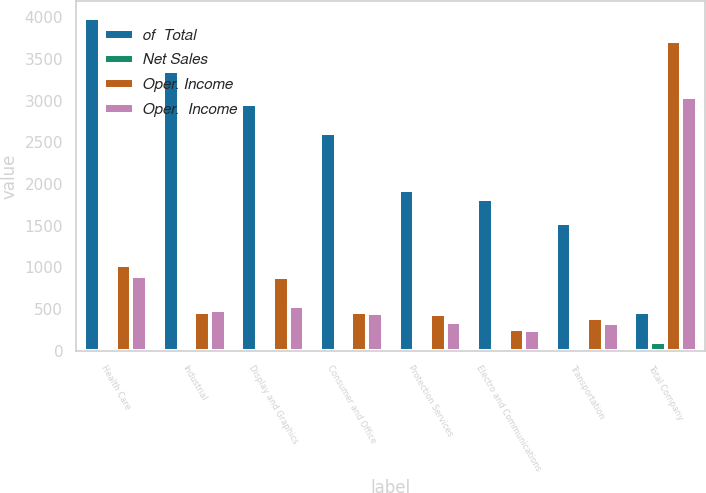Convert chart to OTSL. <chart><loc_0><loc_0><loc_500><loc_500><stacked_bar_chart><ecel><fcel>Health Care<fcel>Industrial<fcel>Display and Graphics<fcel>Consumer and Office<fcel>Protection Services<fcel>Electro and Communications<fcel>Transportation<fcel>Total Company<nl><fcel>of  Total<fcel>3995<fcel>3354<fcel>2962<fcel>2607<fcel>1928<fcel>1818<fcel>1538<fcel>458<nl><fcel>Net Sales<fcel>21.9<fcel>18.4<fcel>16.2<fcel>14.3<fcel>10.6<fcel>10<fcel>8.4<fcel>100<nl><fcel>Oper. Income<fcel>1027<fcel>458<fcel>885<fcel>460<fcel>437<fcel>255<fcel>389<fcel>3713<nl><fcel>Oper.  Income<fcel>900<fcel>487<fcel>534<fcel>448<fcel>338<fcel>253<fcel>333<fcel>3046<nl></chart> 